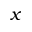Convert formula to latex. <formula><loc_0><loc_0><loc_500><loc_500>x</formula> 